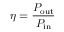Convert formula to latex. <formula><loc_0><loc_0><loc_500><loc_500>\eta = { \frac { P _ { o u t } } { P _ { i n } } }</formula> 